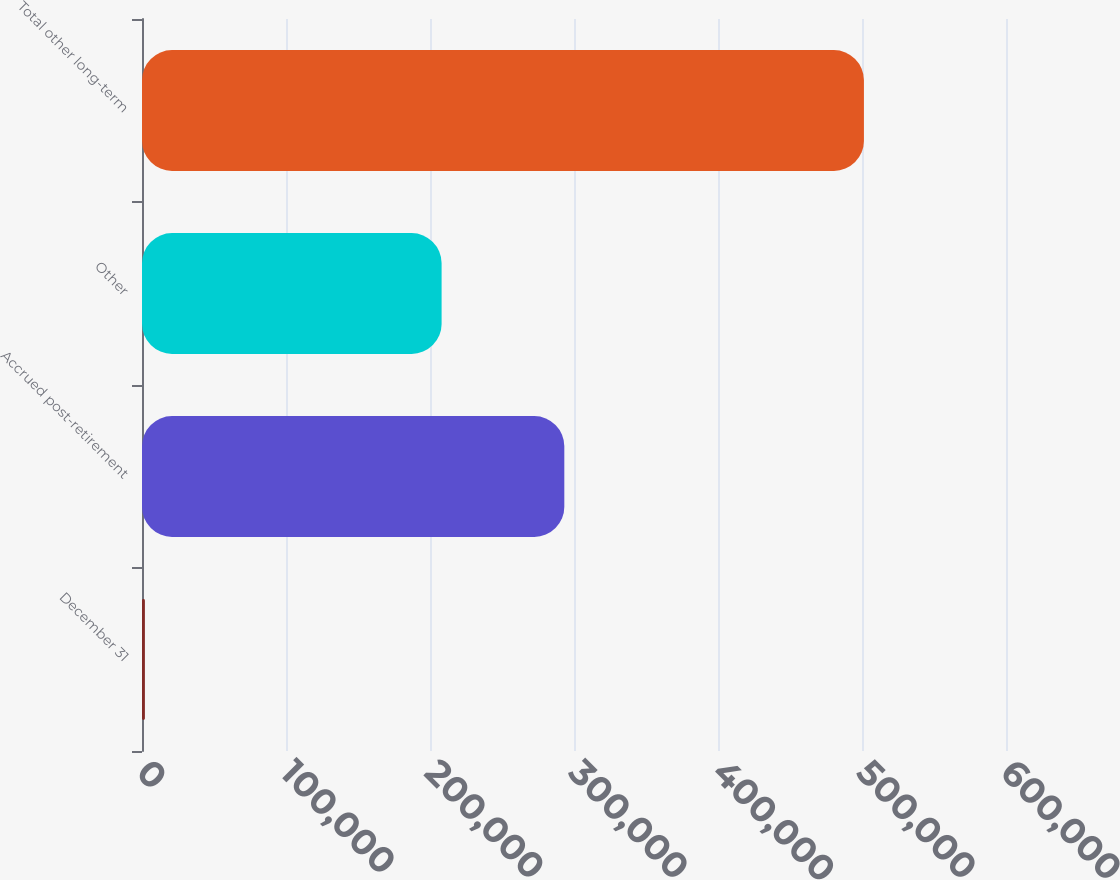<chart> <loc_0><loc_0><loc_500><loc_500><bar_chart><fcel>December 31<fcel>Accrued post-retirement<fcel>Other<fcel>Total other long-term<nl><fcel>2009<fcel>293273<fcel>208061<fcel>501334<nl></chart> 